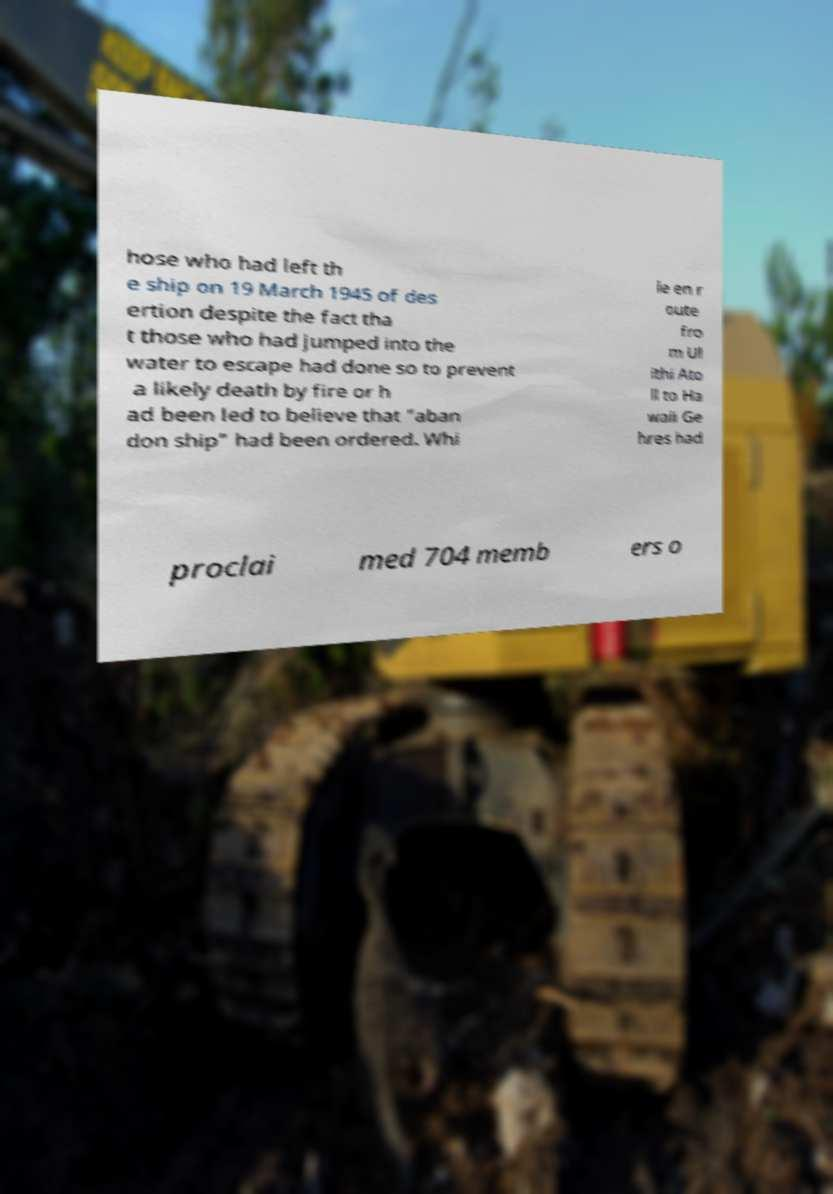There's text embedded in this image that I need extracted. Can you transcribe it verbatim? hose who had left th e ship on 19 March 1945 of des ertion despite the fact tha t those who had jumped into the water to escape had done so to prevent a likely death by fire or h ad been led to believe that "aban don ship" had been ordered. Whi le en r oute fro m Ul ithi Ato ll to Ha waii Ge hres had proclai med 704 memb ers o 